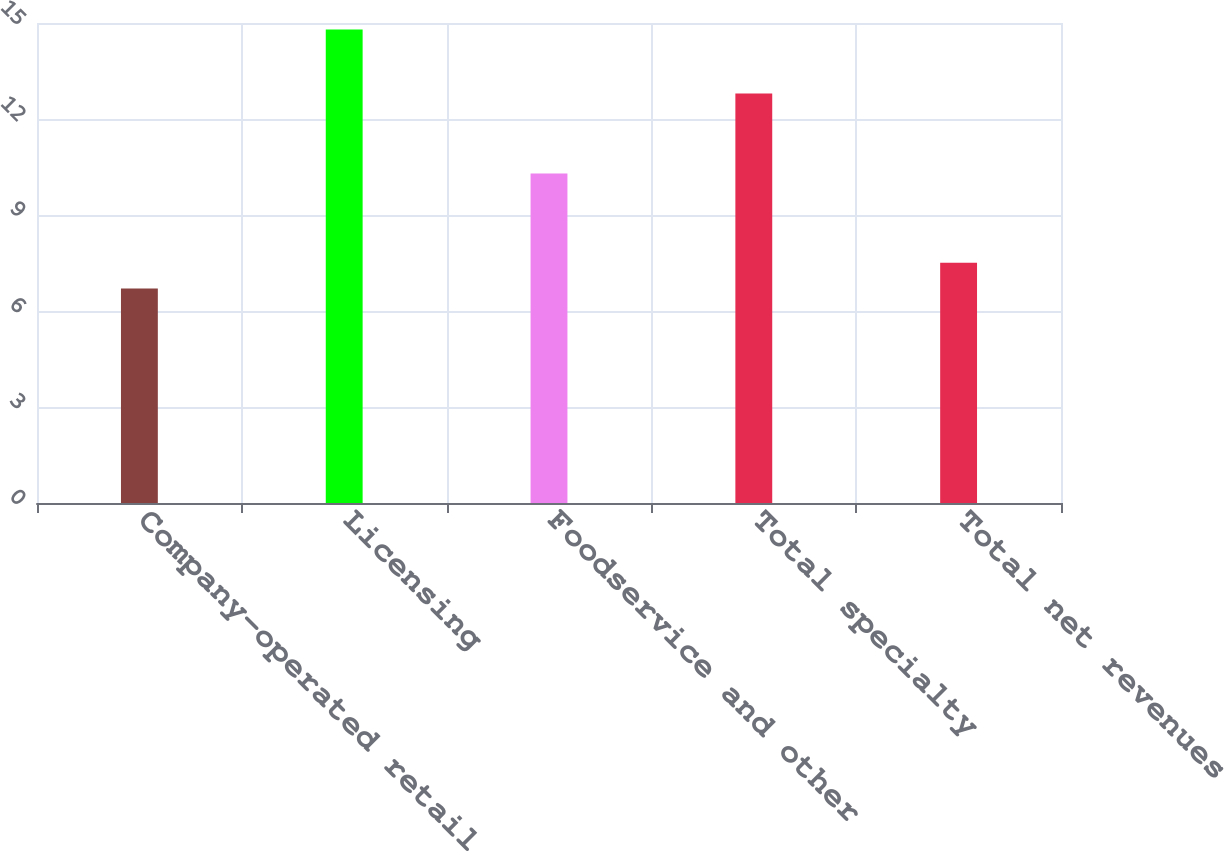Convert chart to OTSL. <chart><loc_0><loc_0><loc_500><loc_500><bar_chart><fcel>Company-operated retail<fcel>Licensing<fcel>Foodservice and other<fcel>Total specialty<fcel>Total net revenues<nl><fcel>6.7<fcel>14.8<fcel>10.3<fcel>12.8<fcel>7.51<nl></chart> 